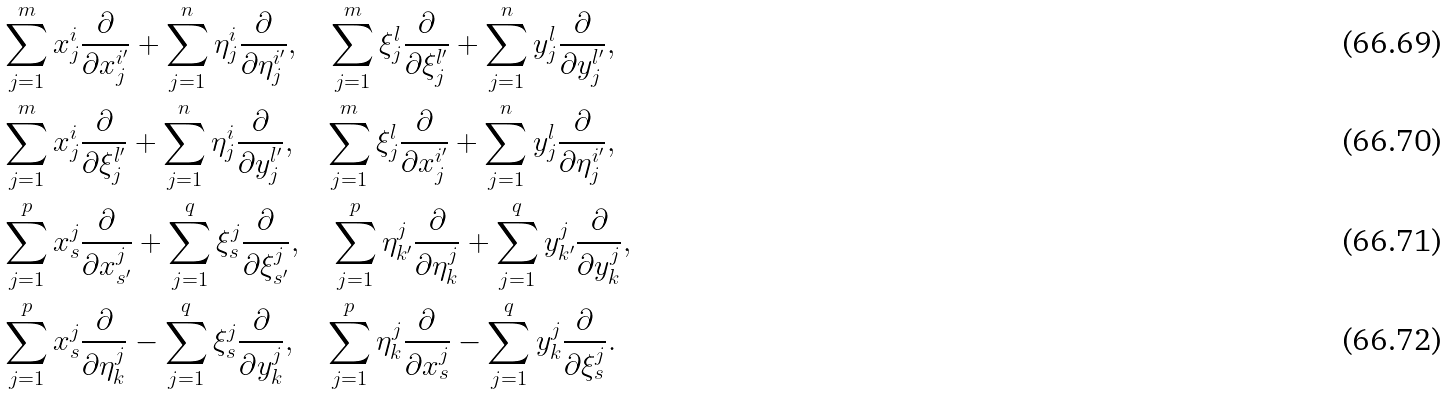Convert formula to latex. <formula><loc_0><loc_0><loc_500><loc_500>& \sum _ { j = 1 } ^ { m } x _ { j } ^ { i } \frac { \partial } { \partial x _ { j } ^ { i ^ { \prime } } } + \sum _ { j = 1 } ^ { n } \eta _ { j } ^ { i } \frac { \partial } { \partial \eta _ { j } ^ { i ^ { \prime } } } , \quad \sum _ { j = 1 } ^ { m } \xi _ { j } ^ { l } \frac { \partial } { \partial \xi _ { j } ^ { l ^ { \prime } } } + \sum _ { j = 1 } ^ { n } y _ { j } ^ { l } \frac { \partial } { \partial y _ { j } ^ { l ^ { \prime } } } , \\ & \sum _ { j = 1 } ^ { m } x _ { j } ^ { i } \frac { \partial } { \partial \xi _ { j } ^ { l ^ { \prime } } } + \sum _ { j = 1 } ^ { n } \eta _ { j } ^ { i } \frac { \partial } { \partial y _ { j } ^ { l ^ { \prime } } } , \quad \sum _ { j = 1 } ^ { m } \xi _ { j } ^ { l } \frac { \partial } { \partial x _ { j } ^ { i ^ { \prime } } } + \sum _ { j = 1 } ^ { n } y _ { j } ^ { l } \frac { \partial } { \partial \eta _ { j } ^ { i ^ { \prime } } } , \\ & \sum _ { j = 1 } ^ { p } x _ { s } ^ { j } \frac { \partial } { \partial x _ { s ^ { \prime } } ^ { j } } + \sum _ { j = 1 } ^ { q } \xi _ { s } ^ { j } \frac { \partial } { \partial \xi _ { s ^ { \prime } } ^ { j } } , \quad \sum _ { j = 1 } ^ { p } \eta _ { k ^ { \prime } } ^ { j } \frac { \partial } { \partial \eta _ { k } ^ { j } } + \sum _ { j = 1 } ^ { q } y _ { k ^ { \prime } } ^ { j } \frac { \partial } { \partial y _ { k } ^ { j } } , \\ & \sum _ { j = 1 } ^ { p } x _ { s } ^ { j } \frac { \partial } { \partial \eta _ { k } ^ { j } } - \sum _ { j = 1 } ^ { q } \xi _ { s } ^ { j } \frac { \partial } { \partial y _ { k } ^ { j } } , \quad \sum _ { j = 1 } ^ { p } \eta _ { k } ^ { j } \frac { \partial } { \partial x _ { s } ^ { j } } - \sum _ { j = 1 } ^ { q } y _ { k } ^ { j } \frac { \partial } { \partial \xi _ { s } ^ { j } } .</formula> 